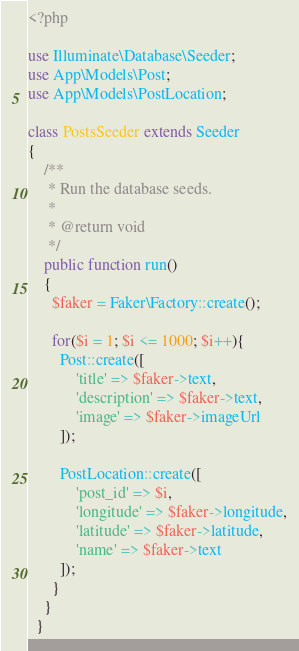Convert code to text. <code><loc_0><loc_0><loc_500><loc_500><_PHP_><?php

use Illuminate\Database\Seeder;
use App\Models\Post;
use App\Models\PostLocation;

class PostsSeeder extends Seeder
{
    /**
     * Run the database seeds.
     *
     * @return void
     */
    public function run()
    {
      $faker = Faker\Factory::create();

      for($i = 1; $i <= 1000; $i++){
        Post::create([
            'title' => $faker->text,
            'description' => $faker->text,
            'image' => $faker->imageUrl
        ]);

        PostLocation::create([
            'post_id' => $i,
            'longitude' => $faker->longitude,
            'latitude' => $faker->latitude,
            'name' => $faker->text
        ]);
      }
    }
  }
</code> 